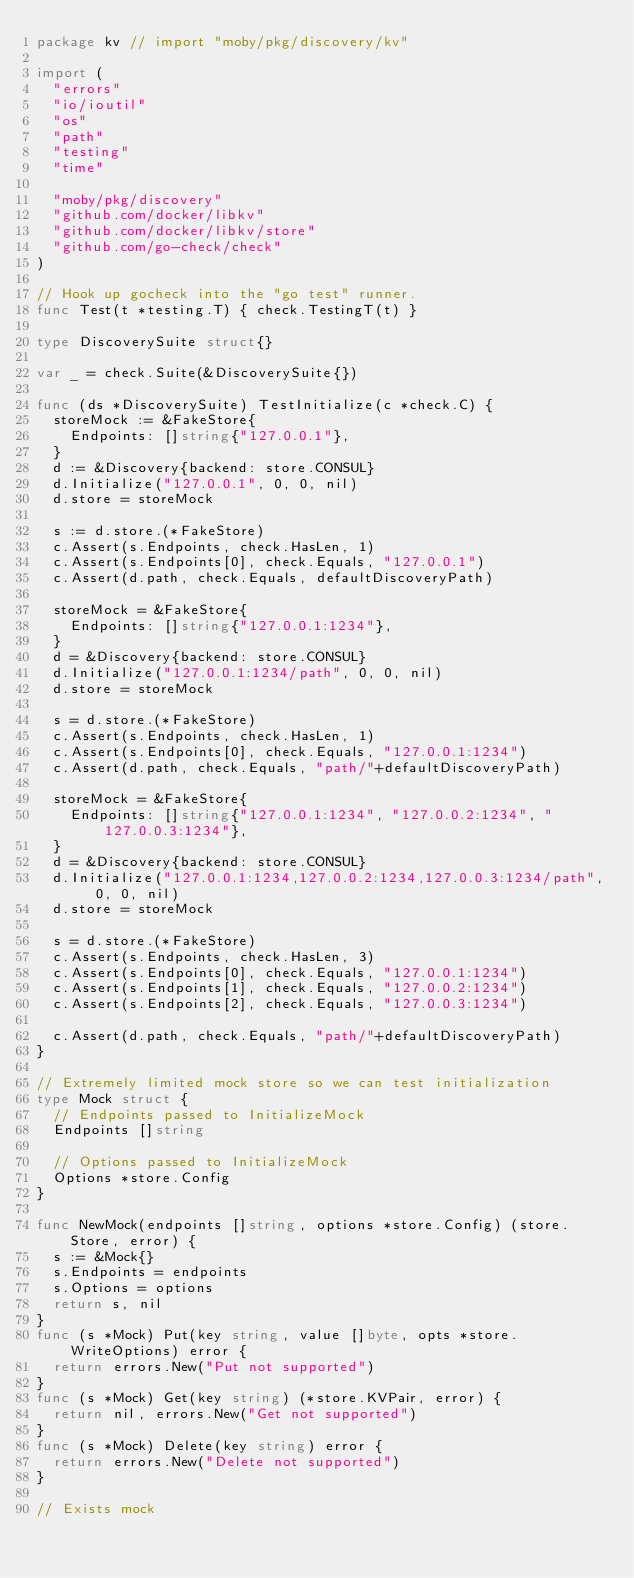<code> <loc_0><loc_0><loc_500><loc_500><_Go_>package kv // import "moby/pkg/discovery/kv"

import (
	"errors"
	"io/ioutil"
	"os"
	"path"
	"testing"
	"time"

	"moby/pkg/discovery"
	"github.com/docker/libkv"
	"github.com/docker/libkv/store"
	"github.com/go-check/check"
)

// Hook up gocheck into the "go test" runner.
func Test(t *testing.T) { check.TestingT(t) }

type DiscoverySuite struct{}

var _ = check.Suite(&DiscoverySuite{})

func (ds *DiscoverySuite) TestInitialize(c *check.C) {
	storeMock := &FakeStore{
		Endpoints: []string{"127.0.0.1"},
	}
	d := &Discovery{backend: store.CONSUL}
	d.Initialize("127.0.0.1", 0, 0, nil)
	d.store = storeMock

	s := d.store.(*FakeStore)
	c.Assert(s.Endpoints, check.HasLen, 1)
	c.Assert(s.Endpoints[0], check.Equals, "127.0.0.1")
	c.Assert(d.path, check.Equals, defaultDiscoveryPath)

	storeMock = &FakeStore{
		Endpoints: []string{"127.0.0.1:1234"},
	}
	d = &Discovery{backend: store.CONSUL}
	d.Initialize("127.0.0.1:1234/path", 0, 0, nil)
	d.store = storeMock

	s = d.store.(*FakeStore)
	c.Assert(s.Endpoints, check.HasLen, 1)
	c.Assert(s.Endpoints[0], check.Equals, "127.0.0.1:1234")
	c.Assert(d.path, check.Equals, "path/"+defaultDiscoveryPath)

	storeMock = &FakeStore{
		Endpoints: []string{"127.0.0.1:1234", "127.0.0.2:1234", "127.0.0.3:1234"},
	}
	d = &Discovery{backend: store.CONSUL}
	d.Initialize("127.0.0.1:1234,127.0.0.2:1234,127.0.0.3:1234/path", 0, 0, nil)
	d.store = storeMock

	s = d.store.(*FakeStore)
	c.Assert(s.Endpoints, check.HasLen, 3)
	c.Assert(s.Endpoints[0], check.Equals, "127.0.0.1:1234")
	c.Assert(s.Endpoints[1], check.Equals, "127.0.0.2:1234")
	c.Assert(s.Endpoints[2], check.Equals, "127.0.0.3:1234")

	c.Assert(d.path, check.Equals, "path/"+defaultDiscoveryPath)
}

// Extremely limited mock store so we can test initialization
type Mock struct {
	// Endpoints passed to InitializeMock
	Endpoints []string

	// Options passed to InitializeMock
	Options *store.Config
}

func NewMock(endpoints []string, options *store.Config) (store.Store, error) {
	s := &Mock{}
	s.Endpoints = endpoints
	s.Options = options
	return s, nil
}
func (s *Mock) Put(key string, value []byte, opts *store.WriteOptions) error {
	return errors.New("Put not supported")
}
func (s *Mock) Get(key string) (*store.KVPair, error) {
	return nil, errors.New("Get not supported")
}
func (s *Mock) Delete(key string) error {
	return errors.New("Delete not supported")
}

// Exists mock</code> 